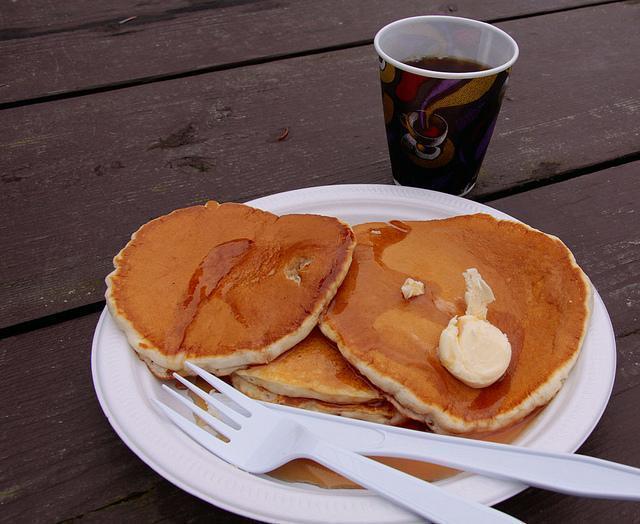On what surface is this plate of pancakes placed upon?
Choose the right answer and clarify with the format: 'Answer: answer
Rationale: rationale.'
Options: Kitchen counter, dining table, desk, park bench. Answer: park bench.
Rationale: There are pancakes on the bench. 